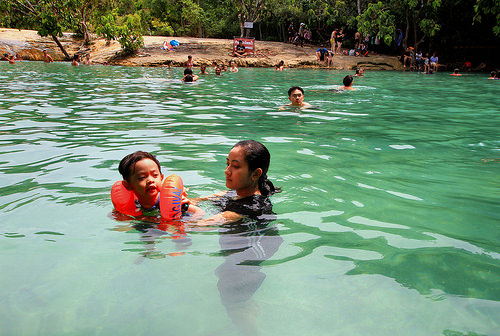<image>
Is the baby behind the pool? No. The baby is not behind the pool. From this viewpoint, the baby appears to be positioned elsewhere in the scene. 